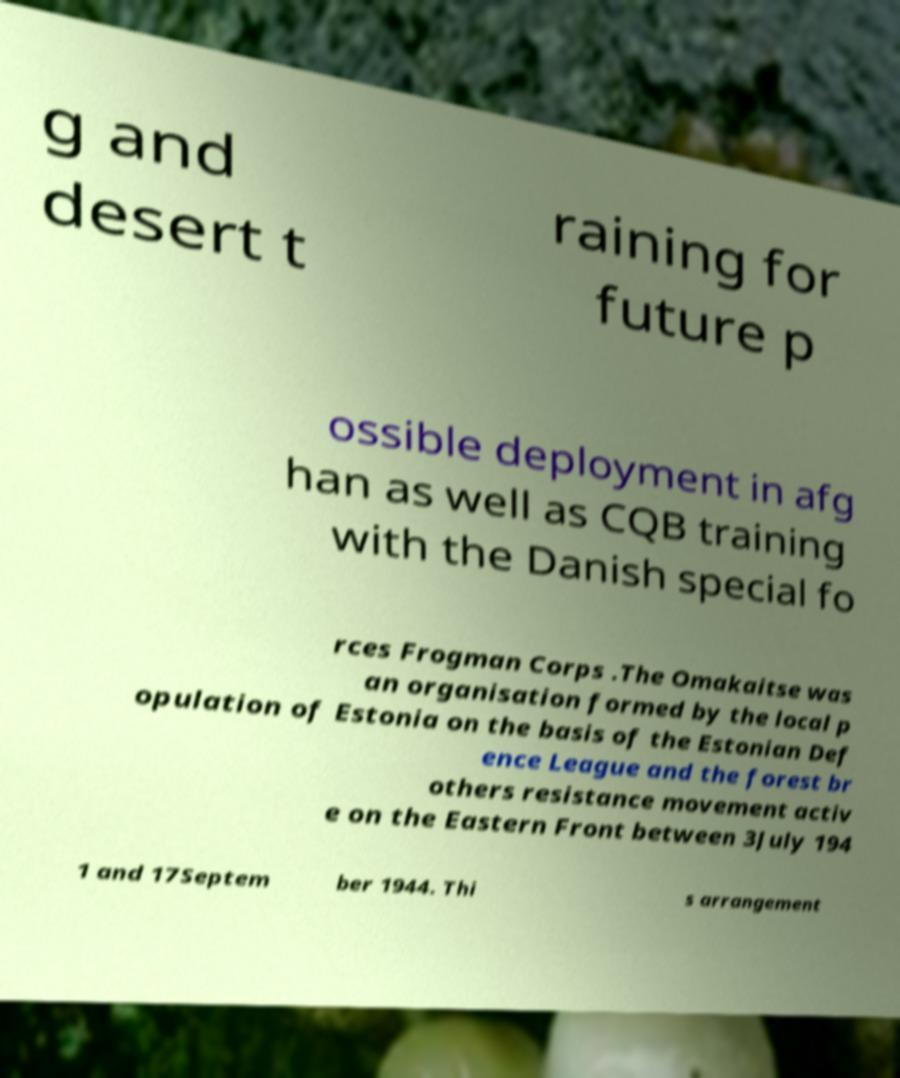I need the written content from this picture converted into text. Can you do that? g and desert t raining for future p ossible deployment in afg han as well as CQB training with the Danish special fo rces Frogman Corps .The Omakaitse was an organisation formed by the local p opulation of Estonia on the basis of the Estonian Def ence League and the forest br others resistance movement activ e on the Eastern Front between 3July 194 1 and 17Septem ber 1944. Thi s arrangement 